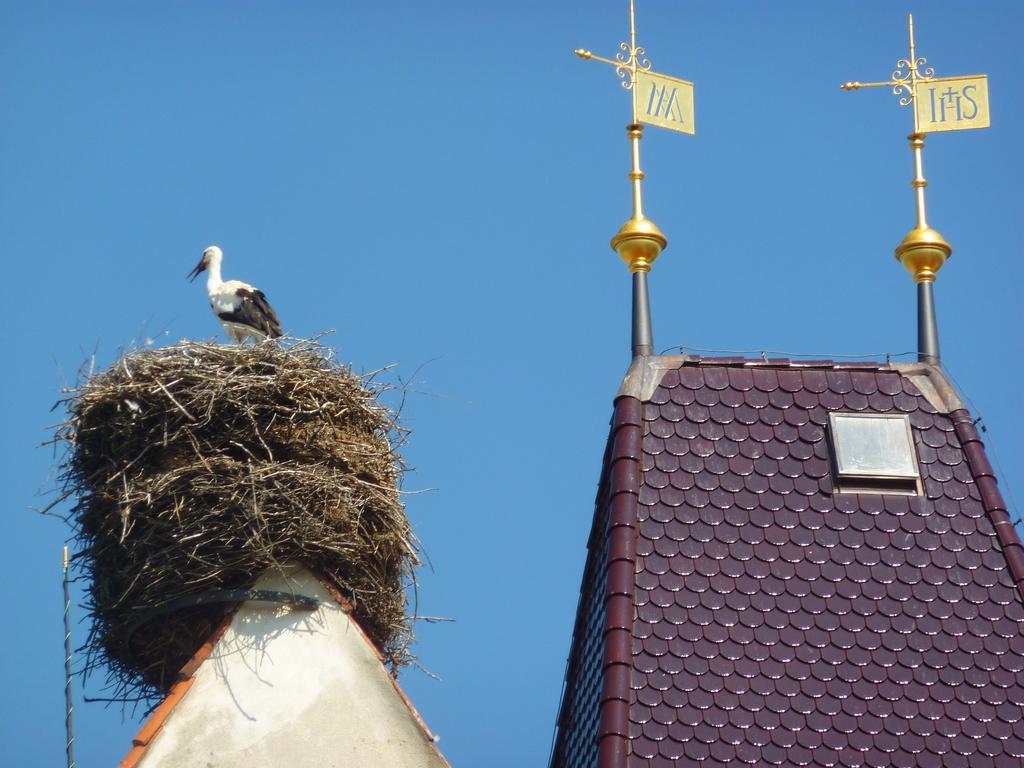In one or two sentences, can you explain what this image depicts? In this image a bird is standing on a nest which is on a house. Right side there is a house having metal rods. Few boards are attached to the metal rods. Background there is sky. 